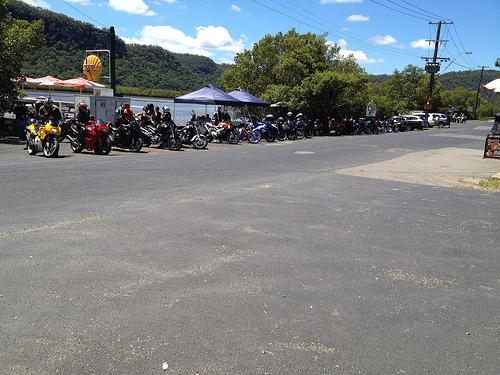Mention the flora present in the image, including the description of any prominent tree. Green foliage covers the hills and a large green tree is present behind the line of motorcycles. Identify any additional elements that can be found in the image, such as power lines or umbrellas. The image shows a telephone pole with power lines, orange-white shade umbrellas, and farmers market purple umbrellas. Name the type of drain found on the road in the image. A sewage drain is present in the middle of the road. Describe the condition of the road in the image, including any notable markings or features. The image shows a paved street with a line of motorcycles and a sewage drain in the middle. The asphalt has two colors. What is the color of the motorcycle with a rider in the image? The motorcycle with a rider is yellow. Describe the condition of the sky in the image, as well as the presence of any water body. The sky is blue with fluffy white clouds, and there is a freshwater lake in the background. What are people doing near the lake in the image? People are sitting under open umbrellas by the lake. What type of coverings are providing shade in the image, and what is their color? Blue tarps are providing shade in the image. What type of vehicles are predominantly visible in this image, and where are they situated? Motorcycles are predominantly visible in the image and are parked in a line on the street. Identify the type of establishment present in the image and its distinguishing signage. The image shows a Shell gas station, identified by the yellow Shell logo on the roof. Is a large bird perched on the telephone pole with power lines? No, it's not mentioned in the image. Is there a group of bicycle riders in the scene? This instruction is misleading because the image mentions several instances of motorcycles and riders, but not bicycles or bicycle riders. Is there a red shell gas station symbol in the image? The instruction is misleading because the shell gas station symbol in the image is described as "standard" and "yellow," not red. Is the sky filled with dark, stormy clouds above the motorcycles? This instruction is misleading because the sky in the image is described as "blue sky with fluffy white clouds" and "bright blue sky few clouds," not dark and stormy. 